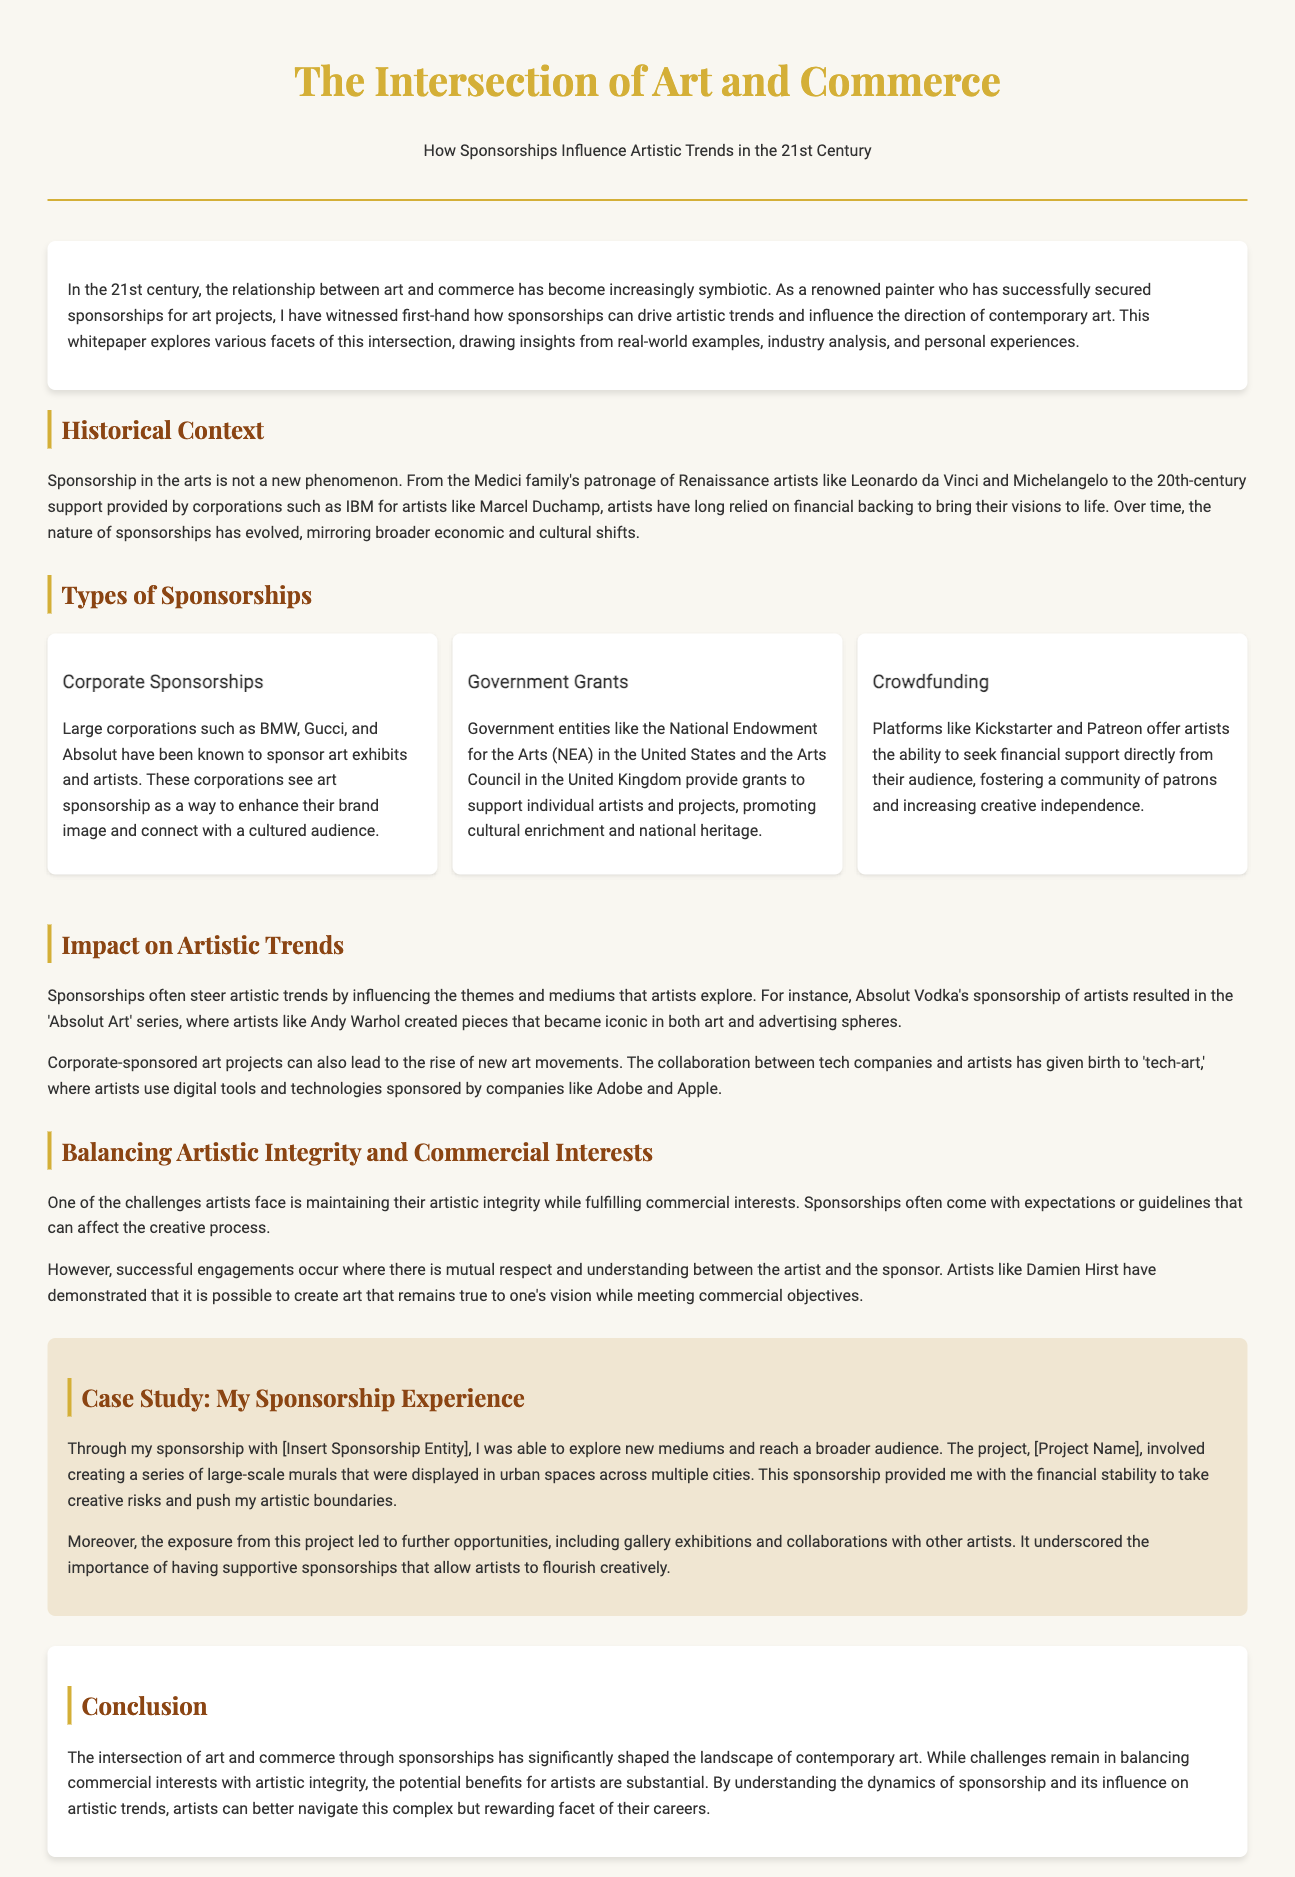What is the title of the whitepaper? The title of the whitepaper is mentioned at the beginning of the document.
Answer: The Intersection of Art and Commerce Who is noted for sponsoring artists like Marcel Duchamp? The document references the support provided by corporations to various artists.
Answer: IBM What type of sponsorship is provided by the National Endowment for the Arts? The specific grant type offered by this entity is discussed in the context of government support.
Answer: Government Grants Which series did Absolut Vodka sponsor that included Andy Warhol? The document mentions a specific art series influenced by sponsorship.
Answer: Absolut Art What is a significant challenge mentioned for artists concerning sponsorships? The document highlights key difficulties artists face related to external financial support.
Answer: Maintaining artistic integrity In what way did the collaboration between tech companies and artists influence art? This aspect is discussed in relation to the rise of new art forms due to corporate sponsorship.
Answer: Tech-art What facilitated the author’s exploration of new mediums? The document describes the source of financial support that allowed creative growth.
Answer: Sponsorship What was the author able to create through their sponsorship project? This detail is outlined in a case study relaying personal experience.
Answer: Large-scale murals 